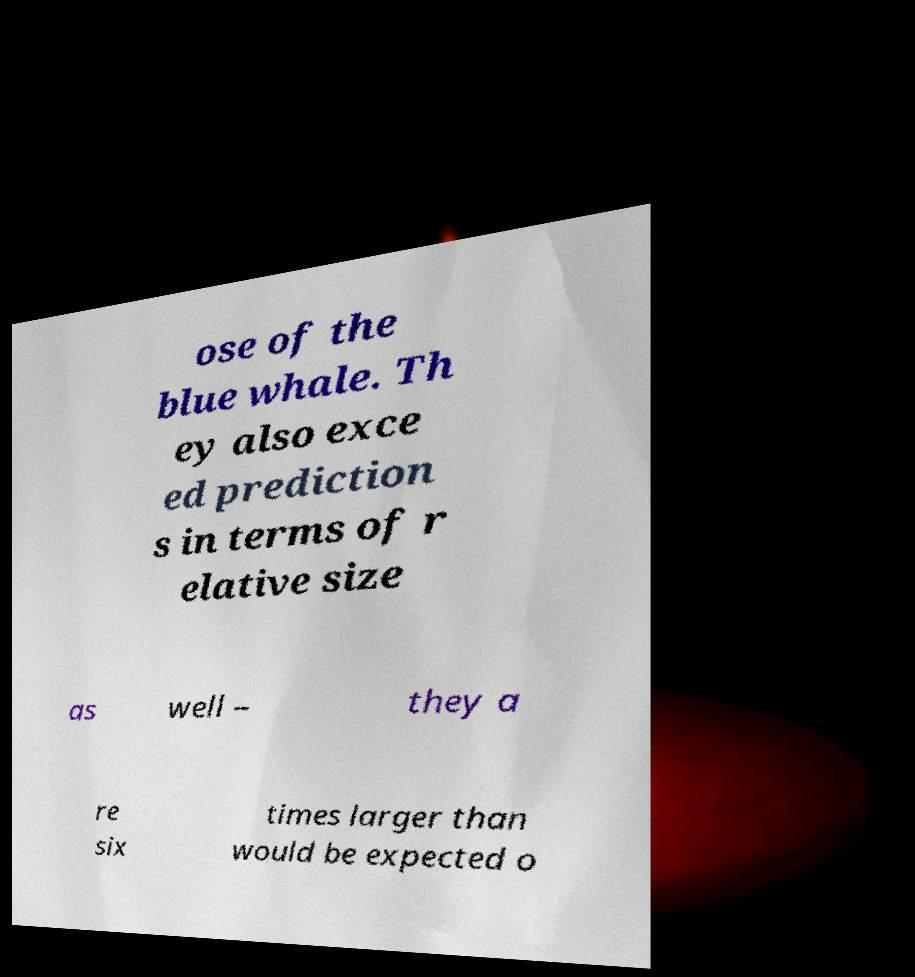There's text embedded in this image that I need extracted. Can you transcribe it verbatim? ose of the blue whale. Th ey also exce ed prediction s in terms of r elative size as well – they a re six times larger than would be expected o 